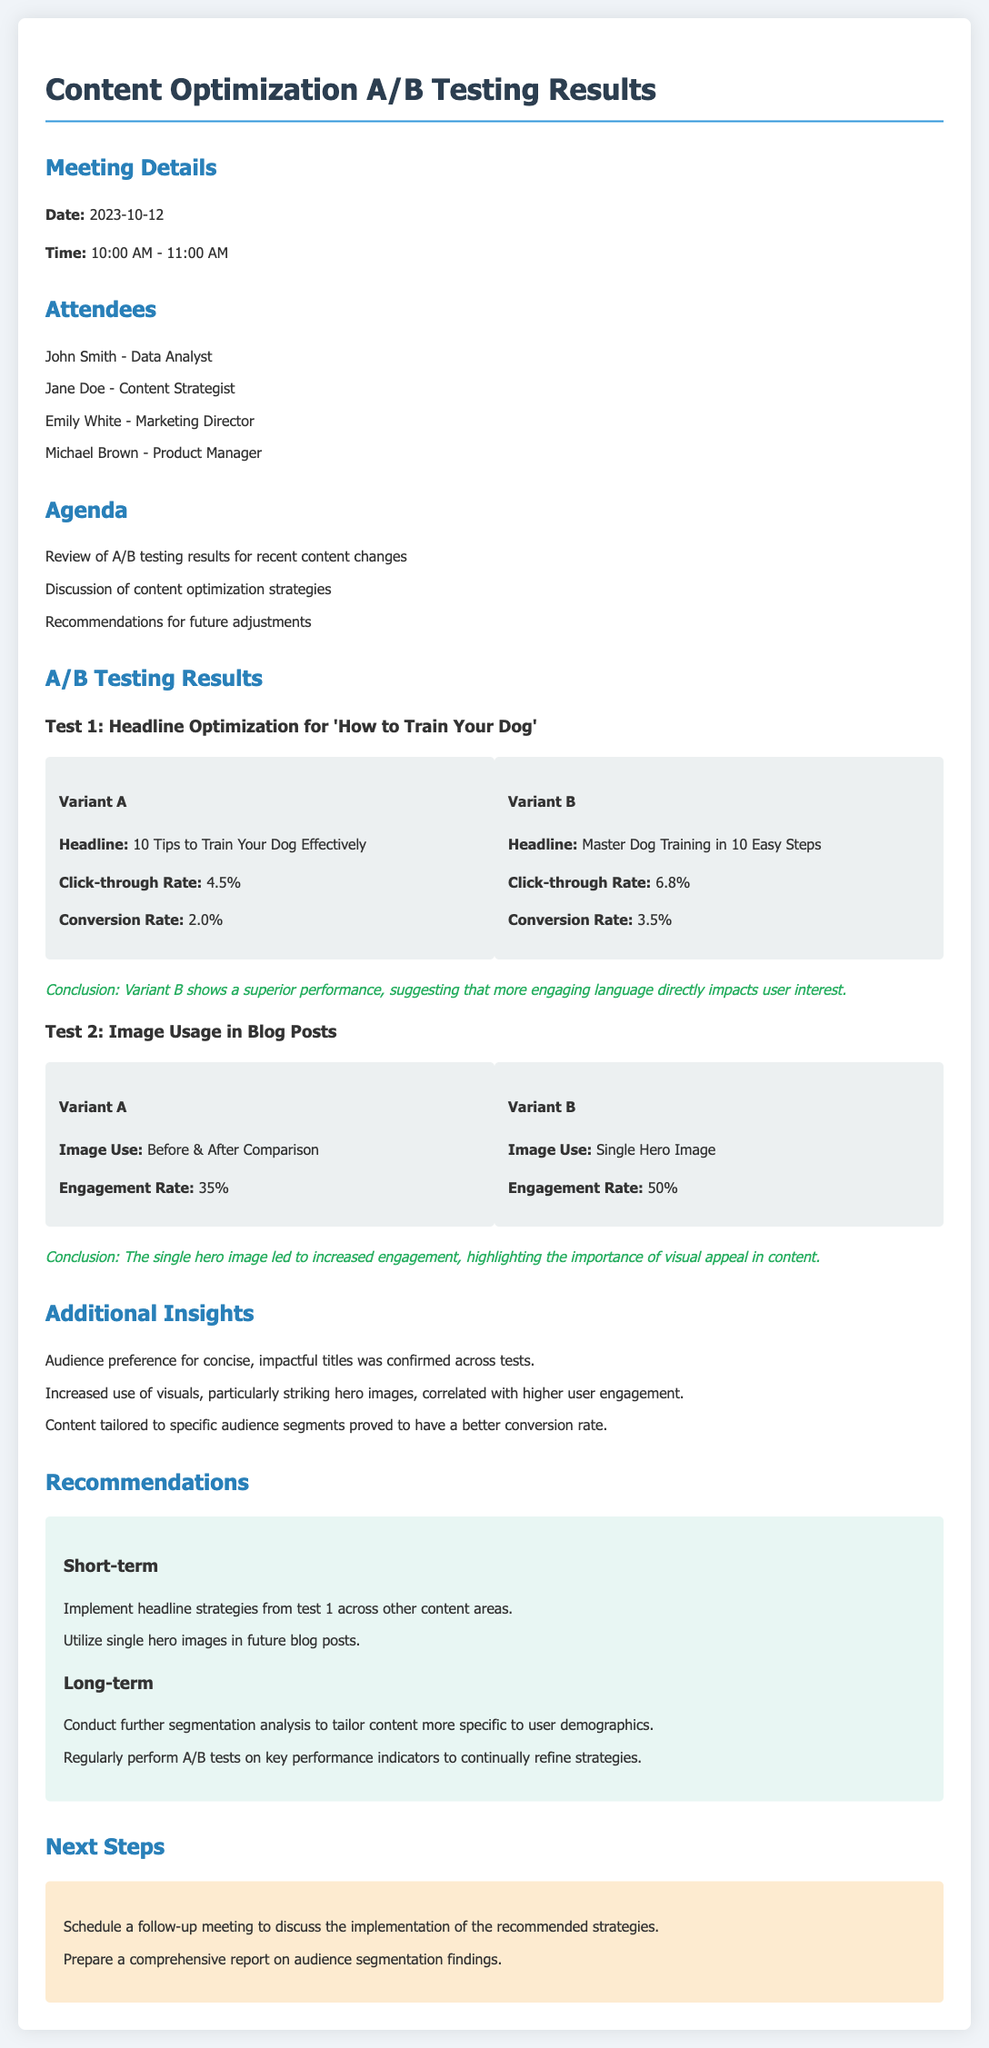what is the date of the meeting? The date of the meeting is provided in the document under "Meeting Details".
Answer: 2023-10-12 who had the highest click-through rate in Test 1? The click-through rates of both variants in Test 1 are compared, and Variant B had the higher rate.
Answer: Variant B what was the engagement rate for Variant B in Test 2? The engagement rate for Variant B is noted in the results of Test 2.
Answer: 50% what are the short-term recommendations from the meeting? The document outlines specific short-term recommendations under the corresponding section.
Answer: Implement headline strategies from test 1 across other content areas which attendees are listed in the meeting minutes? The attendees' names and roles are listed in the document under "Attendees".
Answer: John Smith, Jane Doe, Emily White, Michael Brown how did the use of a single hero image affect engagement? The conclusion drawn from Test 2 directly addresses the impact of the single hero image on engagement.
Answer: Increased engagement what was the purpose of the follow-up meeting mentioned in the next steps? The Next Steps section specifies the purpose of the follow-up meeting concerning strategies discussed.
Answer: Discuss the implementation of the recommended strategies what conclusion was drawn from Test 1? A conclusion about the performance of the variants in Test 1 can be found in the corresponding section of the document.
Answer: Variant B shows a superior performance what was highlighted as important for content in the additional insights section? The document outlines several insights, with a focus on audience preferences and content effectiveness.
Answer: Visual appeal in content 